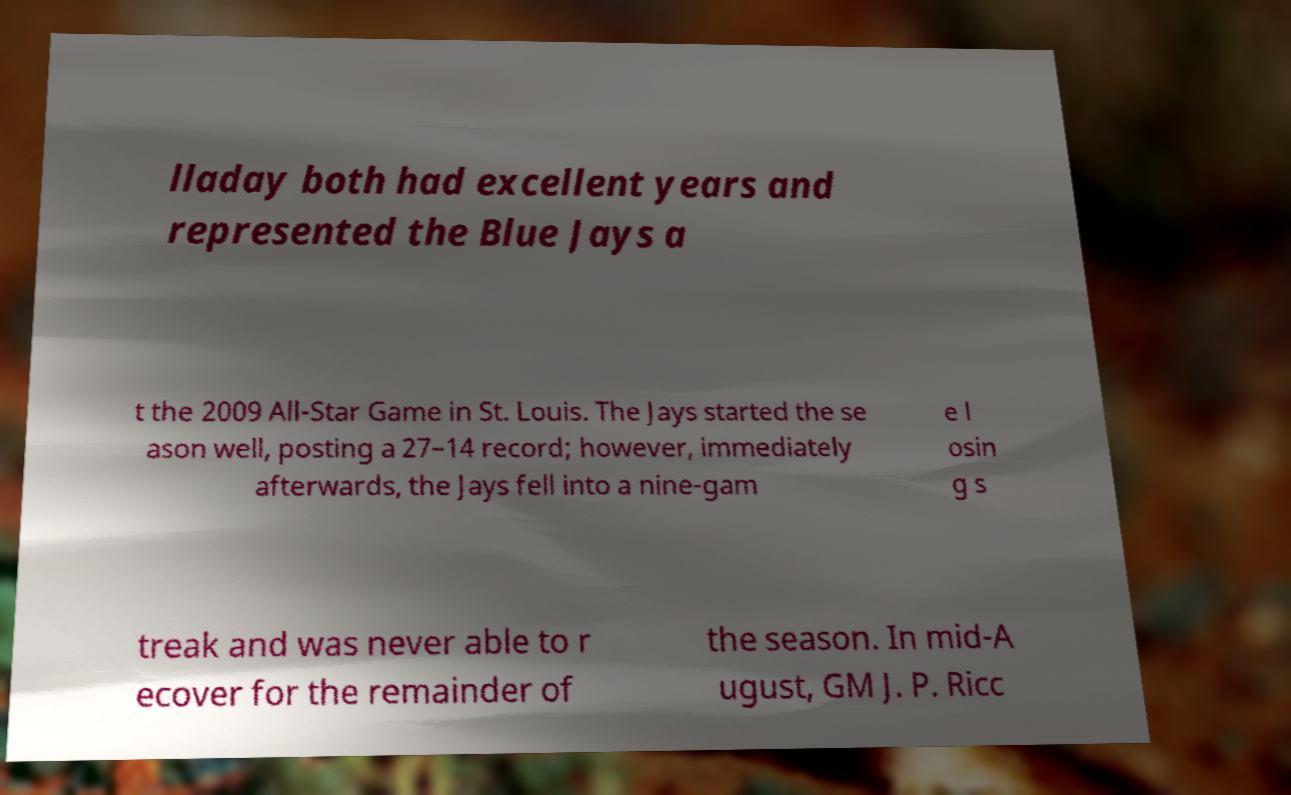What messages or text are displayed in this image? I need them in a readable, typed format. lladay both had excellent years and represented the Blue Jays a t the 2009 All-Star Game in St. Louis. The Jays started the se ason well, posting a 27–14 record; however, immediately afterwards, the Jays fell into a nine-gam e l osin g s treak and was never able to r ecover for the remainder of the season. In mid-A ugust, GM J. P. Ricc 